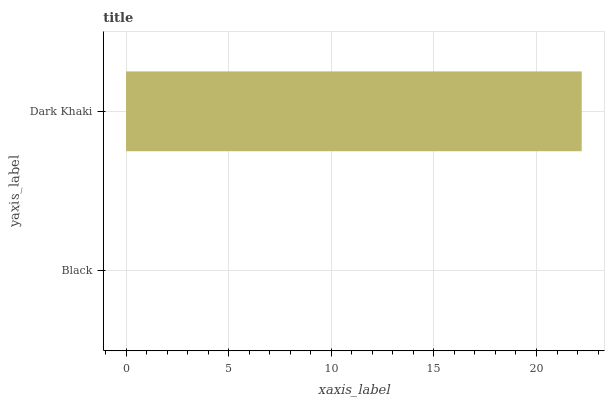Is Black the minimum?
Answer yes or no. Yes. Is Dark Khaki the maximum?
Answer yes or no. Yes. Is Dark Khaki the minimum?
Answer yes or no. No. Is Dark Khaki greater than Black?
Answer yes or no. Yes. Is Black less than Dark Khaki?
Answer yes or no. Yes. Is Black greater than Dark Khaki?
Answer yes or no. No. Is Dark Khaki less than Black?
Answer yes or no. No. Is Dark Khaki the high median?
Answer yes or no. Yes. Is Black the low median?
Answer yes or no. Yes. Is Black the high median?
Answer yes or no. No. Is Dark Khaki the low median?
Answer yes or no. No. 